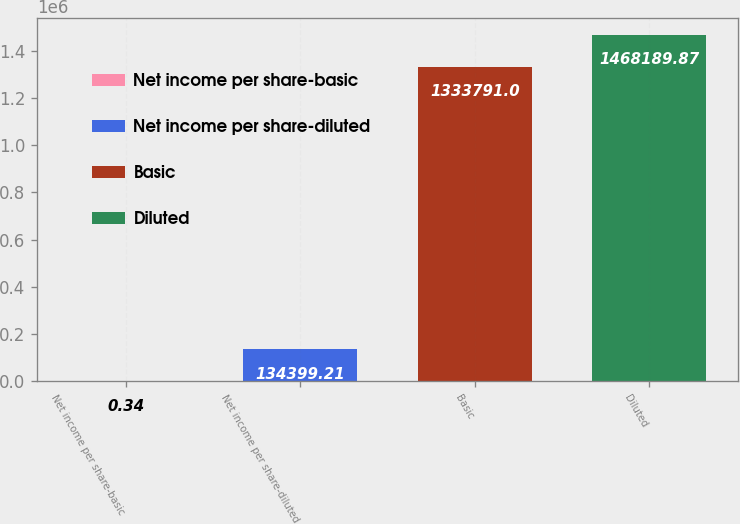Convert chart to OTSL. <chart><loc_0><loc_0><loc_500><loc_500><bar_chart><fcel>Net income per share-basic<fcel>Net income per share-diluted<fcel>Basic<fcel>Diluted<nl><fcel>0.34<fcel>134399<fcel>1.33379e+06<fcel>1.46819e+06<nl></chart> 